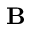<formula> <loc_0><loc_0><loc_500><loc_500>B</formula> 